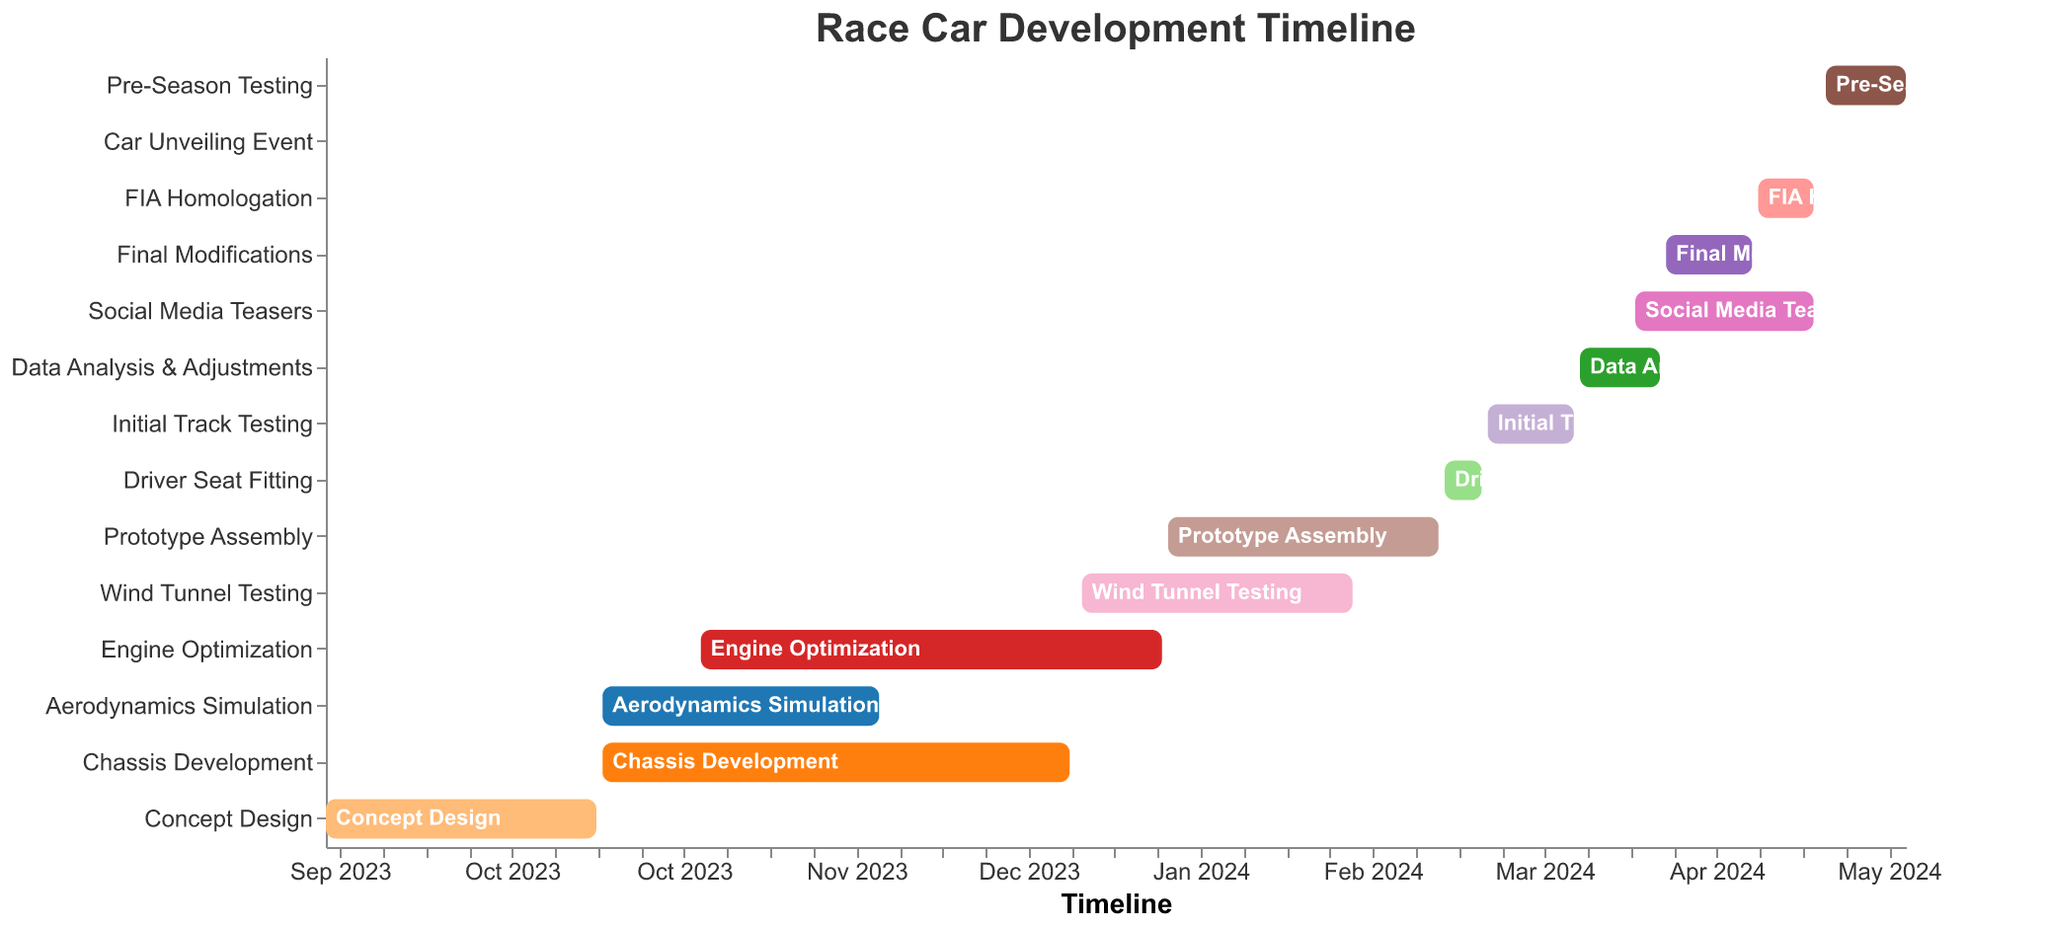What is the title of this Gantt Chart? The title is displayed at the top of the Gantt Chart. The text indicates the main subject of the visualized content.
Answer: Race Car Development Timeline When does the Concept Design phase start and end? By looking at the bar representing 'Concept Design' at the top, we can see its start and end dates marked on the timeline axis.
Answer: Starts: 2023-09-01, Ends: 2023-10-15 Which task lasts the longest? To determine the longest task, compare the lengths of all bars. 'Chassis Development' is visibly the longest.
Answer: Chassis Development What tasks overlap with 'Aerodynamics Simulation'? Check the timeline for tasks starting and ending within the same period. 'Chassis Development' and 'Engine Optimization' overlap with 'Aerodynamics Simulation'.
Answer: Chassis Development, Engine Optimization How long is the 'Prototype Assembly' phase? Calculate the difference between the start and end dates of 'Prototype Assembly'. From 2024-01-16 to 2024-02-29, it spans 1 month and 14 days.
Answer: 1 month 14 days How do the durations of 'Wind Tunnel Testing' and 'Initial Track Testing' compare? Looking at the length of the bars, 'Wind Tunnel Testing' spans from 2024-01-02 to 2024-02-15 (1 month 13 days) and 'Initial Track Testing' from 2024-03-08 to 2024-03-22 (14 days). 'Wind Tunnel Testing' is longer.
Answer: Wind Tunnel Testing > Initial Track Testing What are the final modification tasks before the car unveiling event? Check the timeline for tasks ending just before 'Car Unveiling Event' on 2024-05-01. 'FIA Homologation' and 'Social Media Teasers' end right before.
Answer: FIA Homologation, Social Media Teasers When does the 'Final Modifications' task begin and end? Look at the 'Final Modifications' bar and its start and end dates marked on the timeline axis.
Answer: Starts: 2024-04-06, Ends: 2024-04-20 What is the gap duration between the end of 'Data Analysis & Adjustments' and the start of 'Final Modifications'? 'Data Analysis & Adjustments' ends on 2024-04-05, and 'Final Modifications' starts on 2024-04-06. There is no gap as the next task starts immediately.
Answer: No gap How many tasks are scheduled in April 2024? Count the number of tasks overlapping with April 2024. They are 'Data Analysis & Adjustments', 'Final Modifications', 'FIA Homologation', and 'Social Media Teasers'.
Answer: 4 tasks 